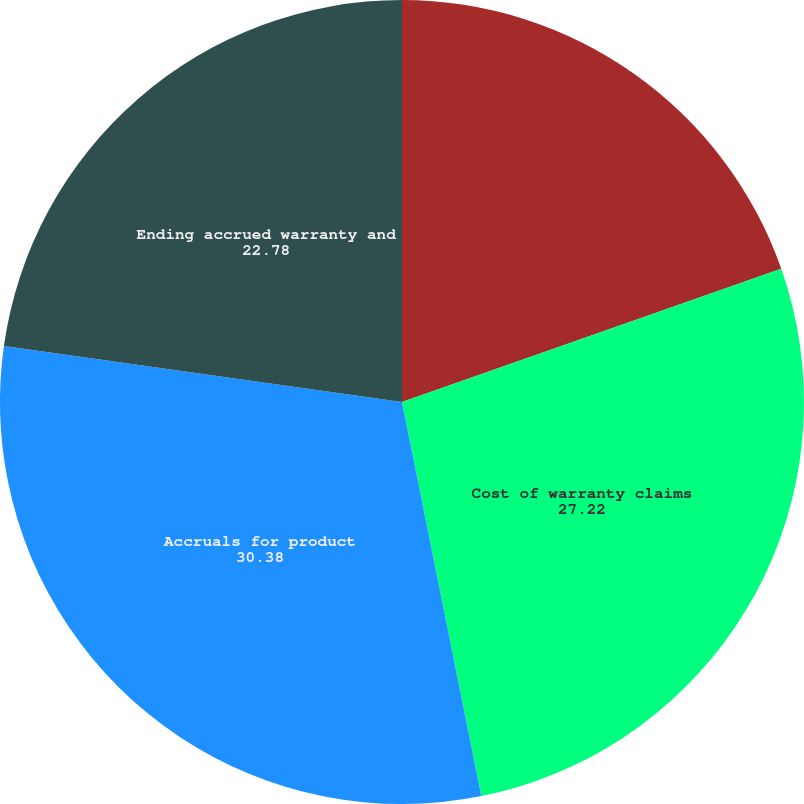<chart> <loc_0><loc_0><loc_500><loc_500><pie_chart><fcel>Beginning accrued warranty and<fcel>Cost of warranty claims<fcel>Accruals for product<fcel>Ending accrued warranty and<nl><fcel>19.62%<fcel>27.22%<fcel>30.38%<fcel>22.78%<nl></chart> 